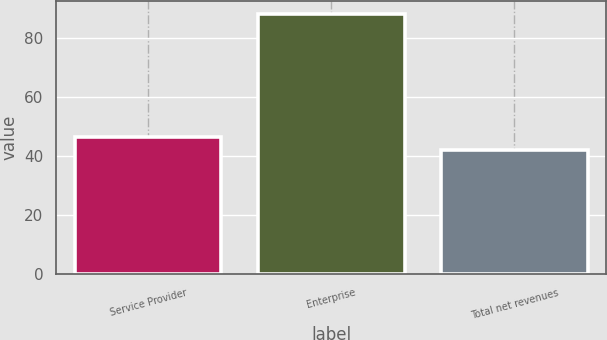Convert chart. <chart><loc_0><loc_0><loc_500><loc_500><bar_chart><fcel>Service Provider<fcel>Enterprise<fcel>Total net revenues<nl><fcel>46.62<fcel>88.2<fcel>42<nl></chart> 